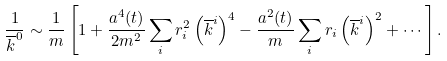Convert formula to latex. <formula><loc_0><loc_0><loc_500><loc_500>\frac { 1 } { \overline { k } ^ { 0 } } \sim \frac { 1 } { m } \left [ 1 + \frac { a ^ { 4 } ( t ) } { 2 m ^ { 2 } } \sum _ { i } r _ { i } ^ { 2 } \left ( \overline { k } ^ { i } \right ) ^ { 4 } - \frac { a ^ { 2 } ( t ) } { m } \sum _ { i } r _ { i } \left ( \overline { k } ^ { i } \right ) ^ { 2 } + \cdots \right ] .</formula> 